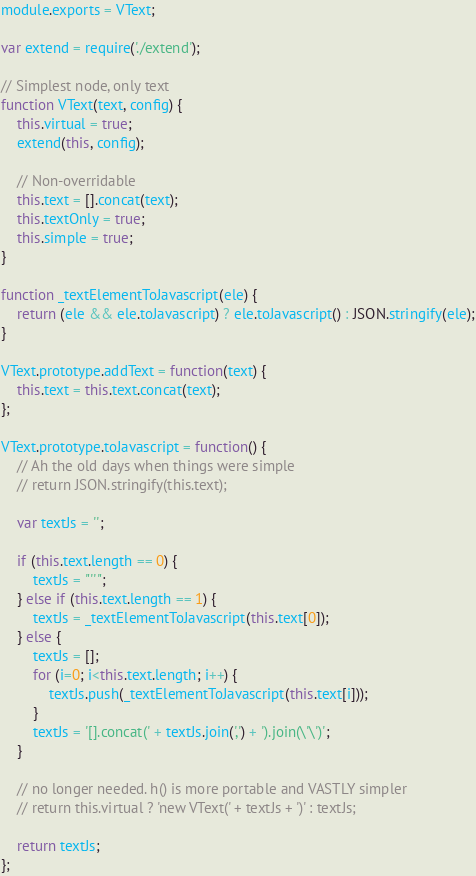<code> <loc_0><loc_0><loc_500><loc_500><_JavaScript_>module.exports = VText;

var extend = require('./extend');

// Simplest node, only text
function VText(text, config) {
	this.virtual = true;
	extend(this, config);

	// Non-overridable
	this.text = [].concat(text);
	this.textOnly = true;
	this.simple = true;
}

function _textElementToJavascript(ele) {
	return (ele && ele.toJavascript) ? ele.toJavascript() : JSON.stringify(ele);
}

VText.prototype.addText = function(text) {
	this.text = this.text.concat(text);
};

VText.prototype.toJavascript = function() {
	// Ah the old days when things were simple
	// return JSON.stringify(this.text);
	
	var textJs = '';
	
	if (this.text.length == 0) {
		textJs = "''";
	} else if (this.text.length == 1) {
		textJs = _textElementToJavascript(this.text[0]);
	} else {
		textJs = [];
		for (i=0; i<this.text.length; i++) {
			textJs.push(_textElementToJavascript(this.text[i]));
		}
		textJs = '[].concat(' + textJs.join(',') + ').join(\'\')';
	}

	// no longer needed. h() is more portable and VASTLY simpler
	// return this.virtual ? 'new VText(' + textJs + ')' : textJs;

	return textJs;
};</code> 